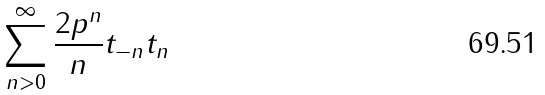<formula> <loc_0><loc_0><loc_500><loc_500>\sum _ { n > 0 } ^ { \infty } \frac { 2 p ^ { n } } { n } t _ { - n } t _ { n }</formula> 